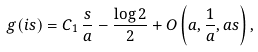<formula> <loc_0><loc_0><loc_500><loc_500>g ( i s ) = C _ { 1 } \, \frac { s } { a } - \frac { \log 2 } { 2 } + O \left ( a , \frac { 1 } { a } , a s \right ) ,</formula> 